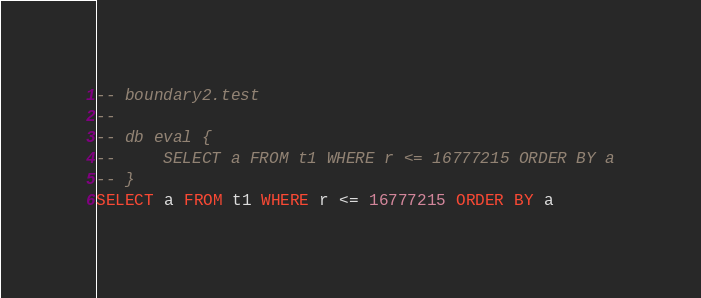Convert code to text. <code><loc_0><loc_0><loc_500><loc_500><_SQL_>-- boundary2.test
-- 
-- db eval {
--     SELECT a FROM t1 WHERE r <= 16777215 ORDER BY a
-- }
SELECT a FROM t1 WHERE r <= 16777215 ORDER BY a</code> 